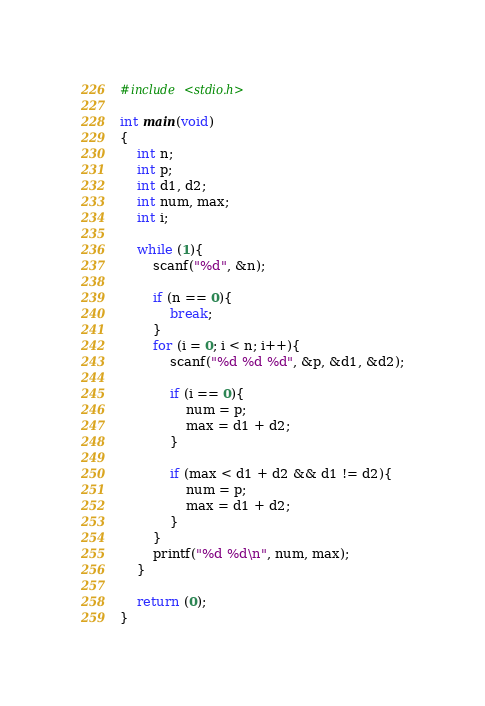Convert code to text. <code><loc_0><loc_0><loc_500><loc_500><_C_>#include <stdio.h>

int main(void)
{
	int n;
	int p;
	int d1, d2;
	int num, max;
	int i;
	
	while (1){
		scanf("%d", &n);
		
		if (n == 0){
			break;
		}
		for (i = 0; i < n; i++){
			scanf("%d %d %d", &p, &d1, &d2);
			
			if (i == 0){
				num = p;
				max = d1 + d2;
			}
			
			if (max < d1 + d2 && d1 != d2){
				num = p;
				max = d1 + d2;
			}
		}
		printf("%d %d\n", num, max);
	}
	
	return (0);
}</code> 